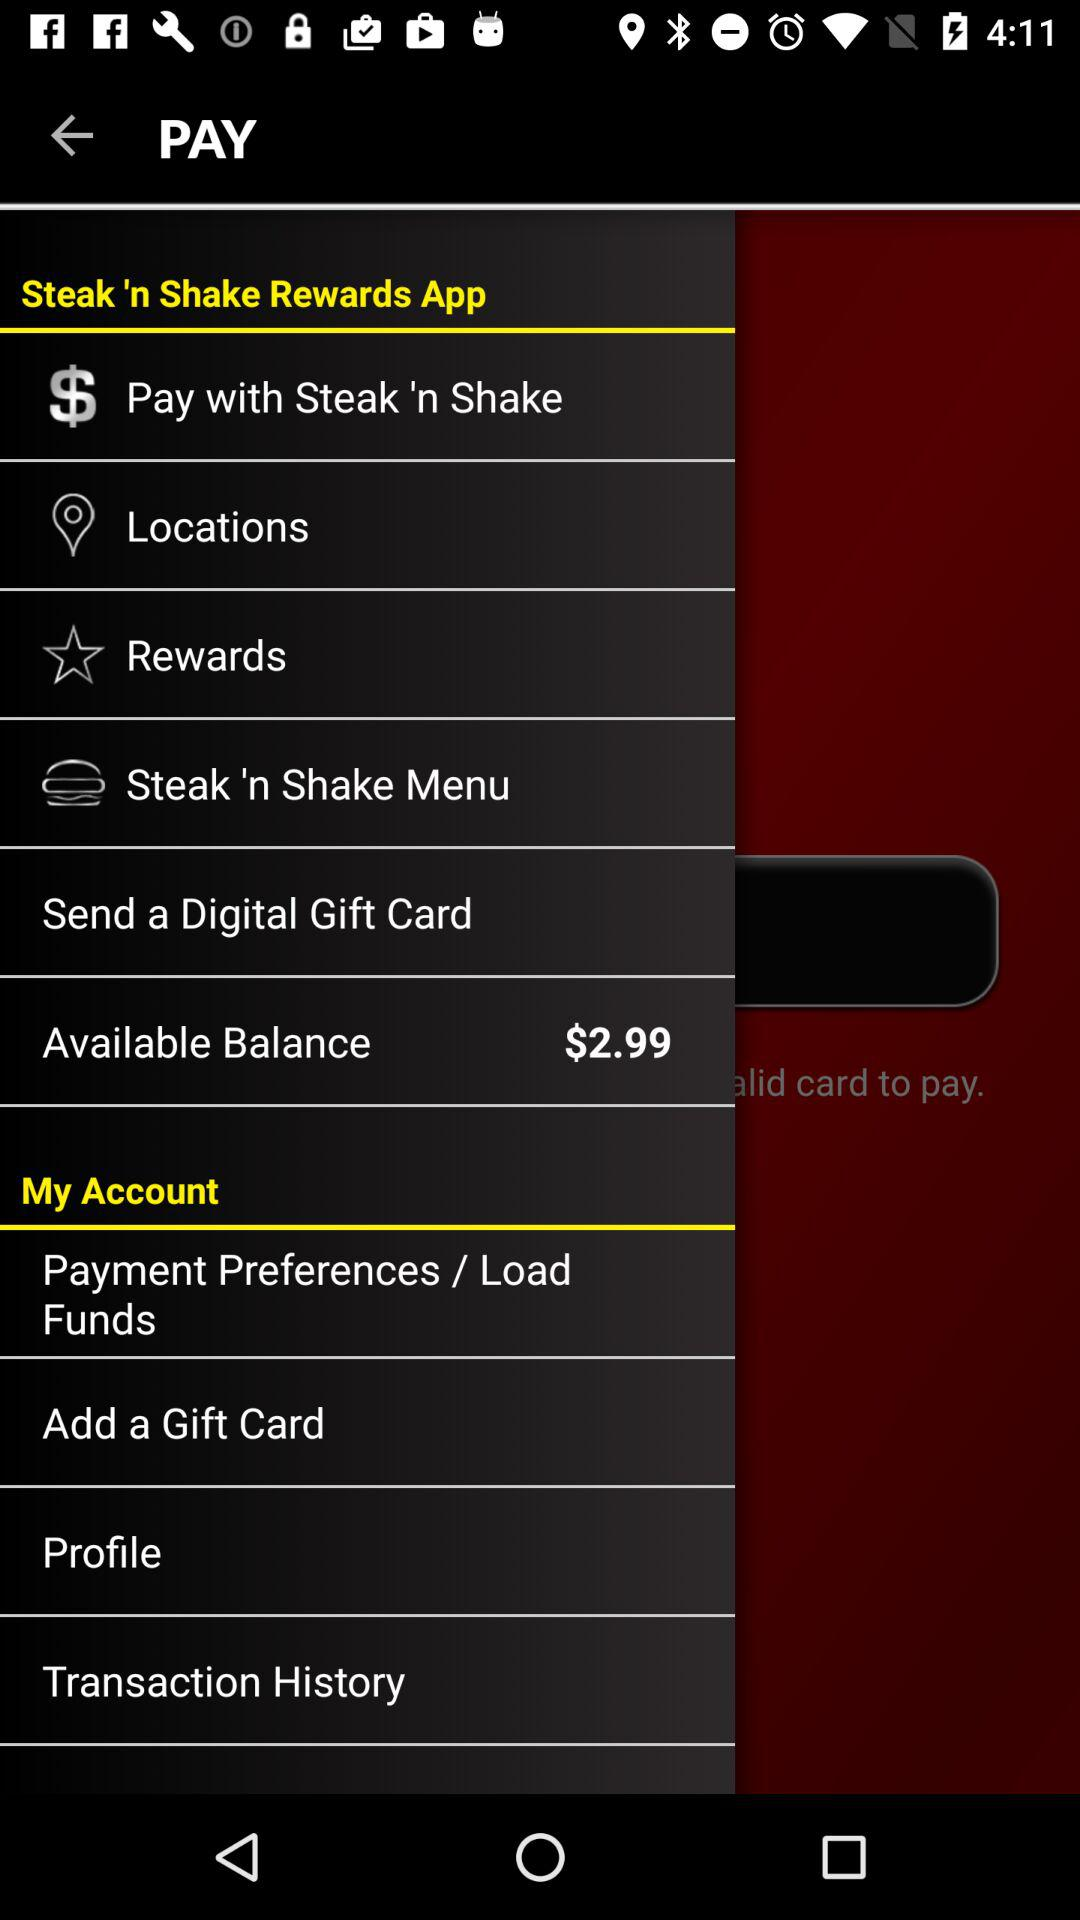How much money is in my available balance?
Answer the question using a single word or phrase. $2.99 